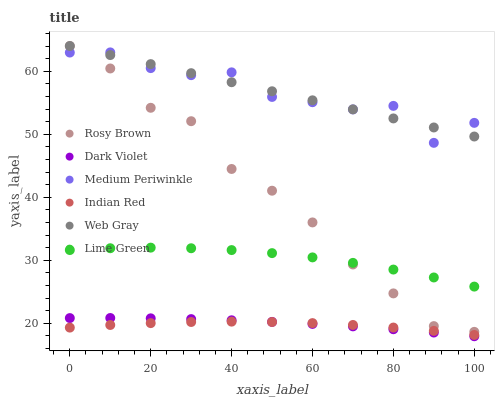Does Indian Red have the minimum area under the curve?
Answer yes or no. Yes. Does Web Gray have the maximum area under the curve?
Answer yes or no. Yes. Does Rosy Brown have the minimum area under the curve?
Answer yes or no. No. Does Rosy Brown have the maximum area under the curve?
Answer yes or no. No. Is Web Gray the smoothest?
Answer yes or no. Yes. Is Medium Periwinkle the roughest?
Answer yes or no. Yes. Is Rosy Brown the smoothest?
Answer yes or no. No. Is Rosy Brown the roughest?
Answer yes or no. No. Does Dark Violet have the lowest value?
Answer yes or no. Yes. Does Rosy Brown have the lowest value?
Answer yes or no. No. Does Rosy Brown have the highest value?
Answer yes or no. Yes. Does Medium Periwinkle have the highest value?
Answer yes or no. No. Is Lime Green less than Web Gray?
Answer yes or no. Yes. Is Lime Green greater than Dark Violet?
Answer yes or no. Yes. Does Rosy Brown intersect Lime Green?
Answer yes or no. Yes. Is Rosy Brown less than Lime Green?
Answer yes or no. No. Is Rosy Brown greater than Lime Green?
Answer yes or no. No. Does Lime Green intersect Web Gray?
Answer yes or no. No. 